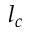<formula> <loc_0><loc_0><loc_500><loc_500>l _ { c }</formula> 